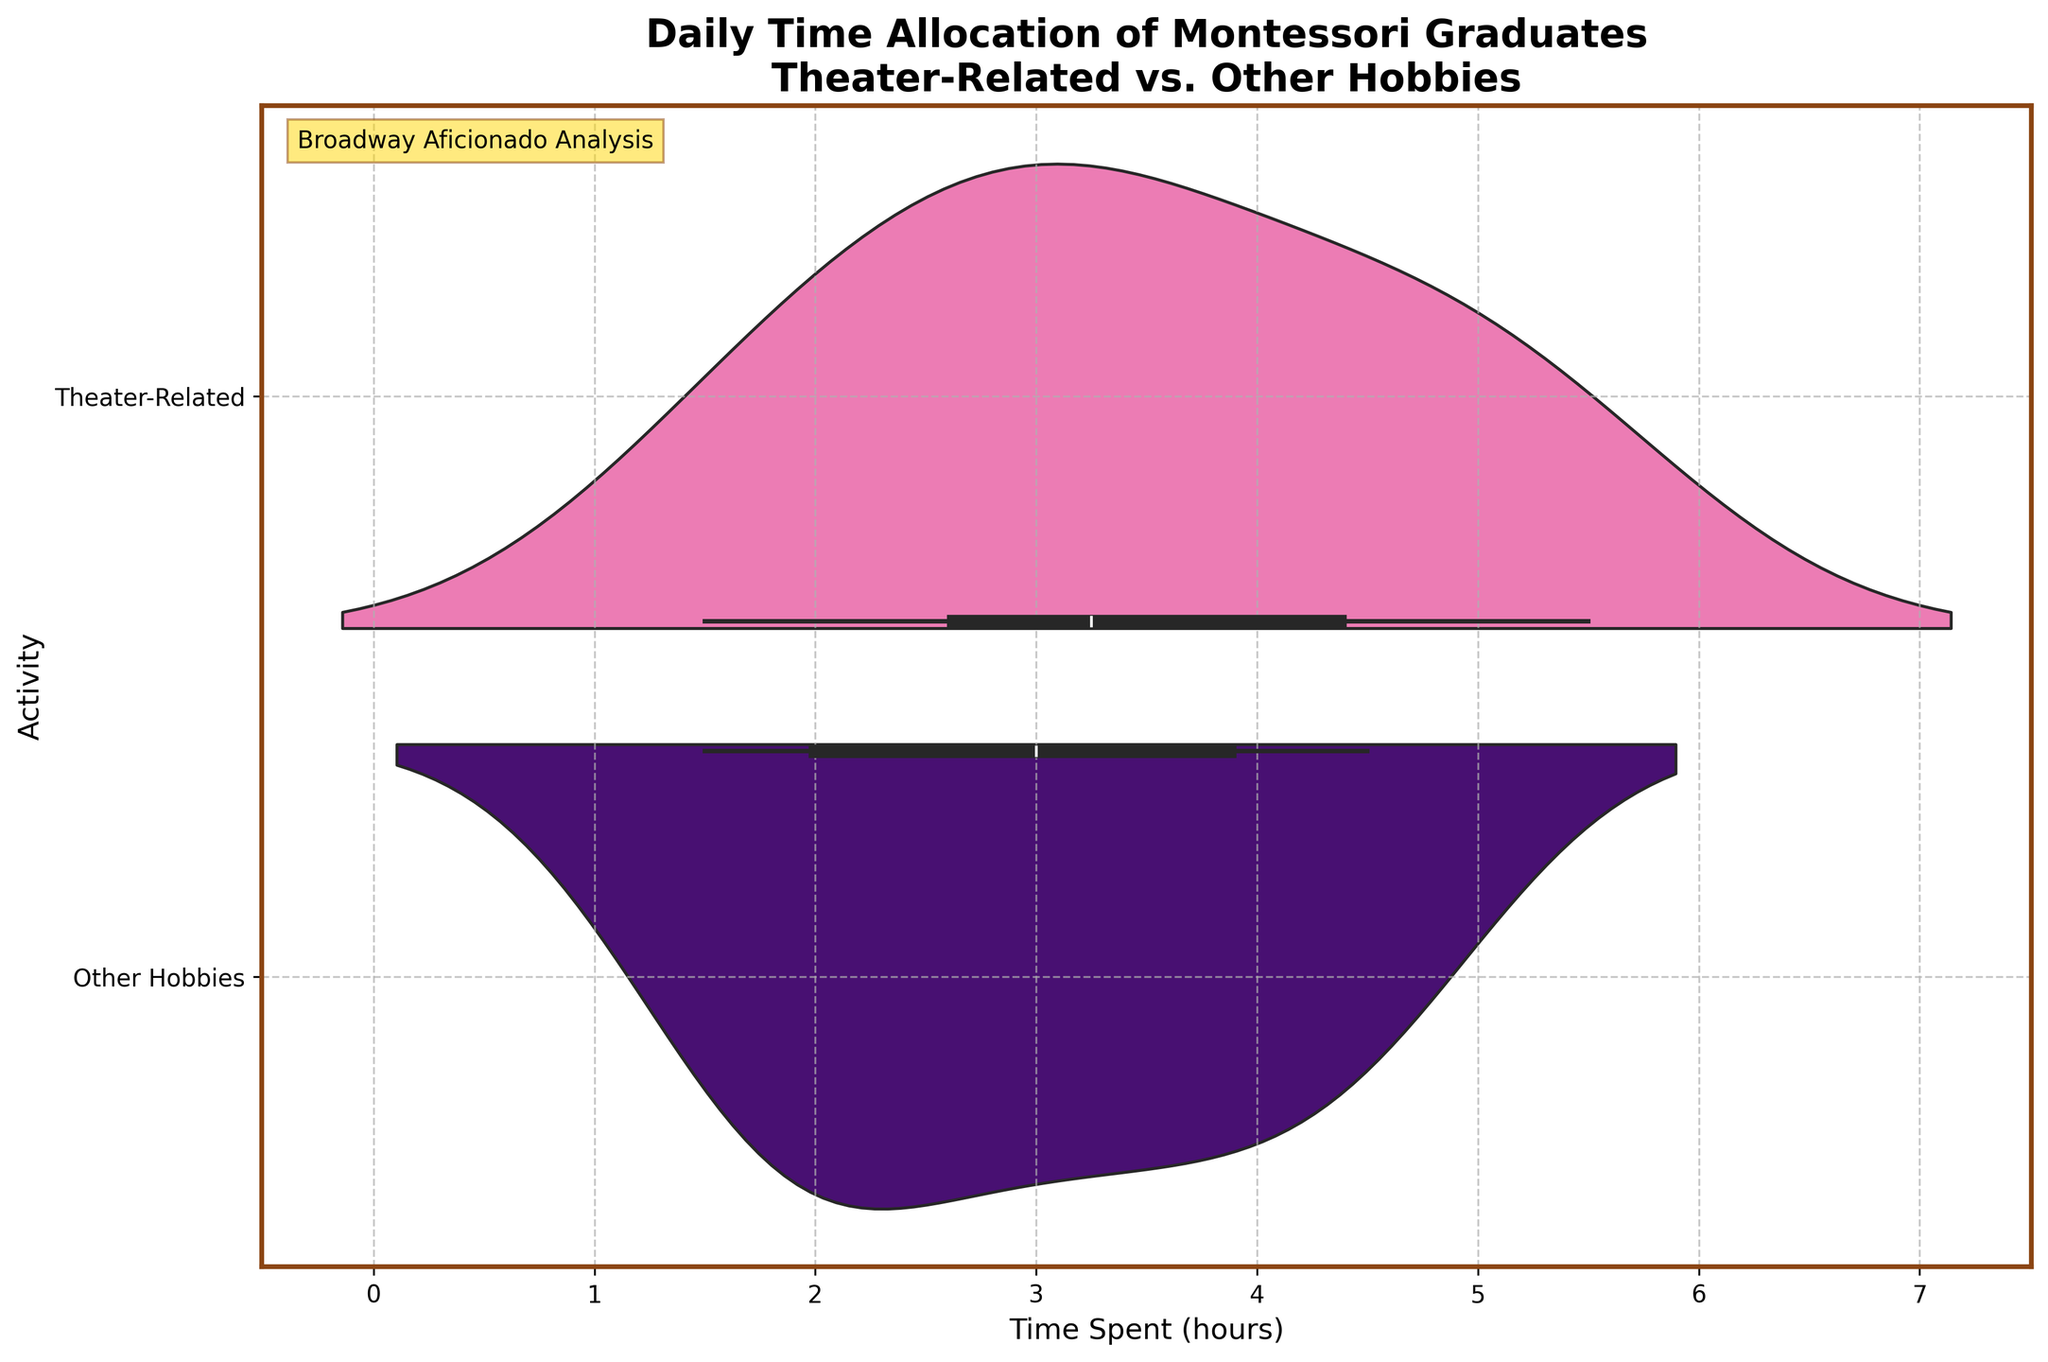How many different activities are represented in the chart? The chart shows two violin plots labeled "Theater-Related" and "Other Hobbies," indicating two different activities.
Answer: 2 What are the colors used for the activities in the chart? The violin plot for "Theater-Related" is colored pink, and the plot for "Other Hobbies" is colored indigo.
Answer: Pink and indigo What is the title of the chart? The title is prominently displayed at the top of the figure and reads "Daily Time Allocation of Montessori Graduates\nTheater-Related vs. Other Hobbies."
Answer: Daily Time Allocation of Montessori Graduates\nTheater-Related vs. Other Hobbies What is the range of time spent on theater-related activities? By observing the horizontal axis and the spread of the violin plot for "Theater-Related," it shows values ranging from approximately 1.5 to 5.5 hours.
Answer: 1.5 to 5.5 hours Which activity has a larger spread in time allocation? Comparing the width of the violin plots horizontally shows that "Other Hobbies" spans a larger range of hours.
Answer: Other Hobbies What's the median time spent on other hobbies? The median is indicated by the peak and densest region of the "Other Hobbies" violin plot, which looks to be around 3 hours.
Answer: Approximately 3 hours Do Montessori graduates spend more time on theater-related activities or other hobbies on average? By comparing the height and density distribution of both violin plots, "Theater-Related" appears to have a higher concentration of longer hours.
Answer: Theater-Related How does the grid layout contribute to the understanding of the data? The grid lines on the chart help to align and compare the distributions of time allocation across the two activities more precisely.
Answer: Improves alignment and comparison Which activity shows a more consistent time allocation among Montessori graduates? The "Other Hobbies" violin plot shows a broader and more varied distribution, while "Theater-Related" has a narrower density, indicating more consistency.
Answer: Theater-Related Why might the text "Broadway Aficionado Analysis" be included in the chart? This annotation is likely added to provide context and emphasize the author's expertise and specialization in theater-related analysis.
Answer: Context and emphasis 